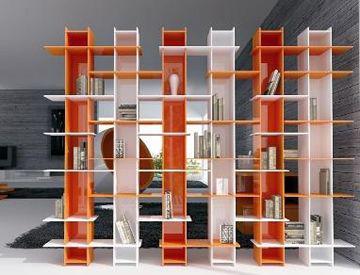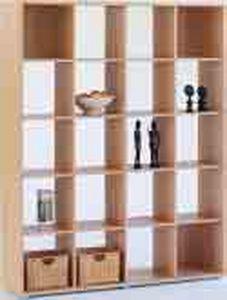The first image is the image on the left, the second image is the image on the right. Analyze the images presented: Is the assertion "In one image, tall, colorful open shelves, that are partly orange, are used as a room divider." valid? Answer yes or no. Yes. The first image is the image on the left, the second image is the image on the right. Given the left and right images, does the statement "Left image shows a free-standing shelf divider featuring orange color." hold true? Answer yes or no. Yes. 